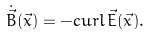Convert formula to latex. <formula><loc_0><loc_0><loc_500><loc_500>\dot { \vec { B } } ( \vec { x } ) = - c u r l \, \vec { E } ( \vec { x } ) .</formula> 